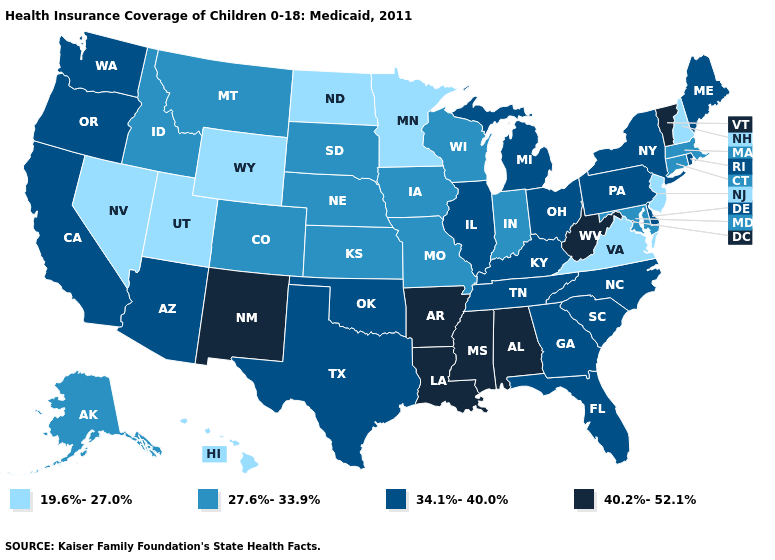Among the states that border North Dakota , which have the highest value?
Short answer required. Montana, South Dakota. Does Alabama have the highest value in the USA?
Quick response, please. Yes. Does Virginia have a lower value than North Dakota?
Short answer required. No. What is the lowest value in the West?
Answer briefly. 19.6%-27.0%. What is the highest value in the MidWest ?
Concise answer only. 34.1%-40.0%. Name the states that have a value in the range 19.6%-27.0%?
Short answer required. Hawaii, Minnesota, Nevada, New Hampshire, New Jersey, North Dakota, Utah, Virginia, Wyoming. Does Minnesota have the lowest value in the MidWest?
Short answer required. Yes. Name the states that have a value in the range 34.1%-40.0%?
Concise answer only. Arizona, California, Delaware, Florida, Georgia, Illinois, Kentucky, Maine, Michigan, New York, North Carolina, Ohio, Oklahoma, Oregon, Pennsylvania, Rhode Island, South Carolina, Tennessee, Texas, Washington. What is the value of Oregon?
Answer briefly. 34.1%-40.0%. Name the states that have a value in the range 40.2%-52.1%?
Write a very short answer. Alabama, Arkansas, Louisiana, Mississippi, New Mexico, Vermont, West Virginia. Does Florida have the highest value in the South?
Write a very short answer. No. What is the value of New York?
Give a very brief answer. 34.1%-40.0%. What is the value of Louisiana?
Be succinct. 40.2%-52.1%. Which states have the highest value in the USA?
Quick response, please. Alabama, Arkansas, Louisiana, Mississippi, New Mexico, Vermont, West Virginia. Does Illinois have the highest value in the MidWest?
Write a very short answer. Yes. 